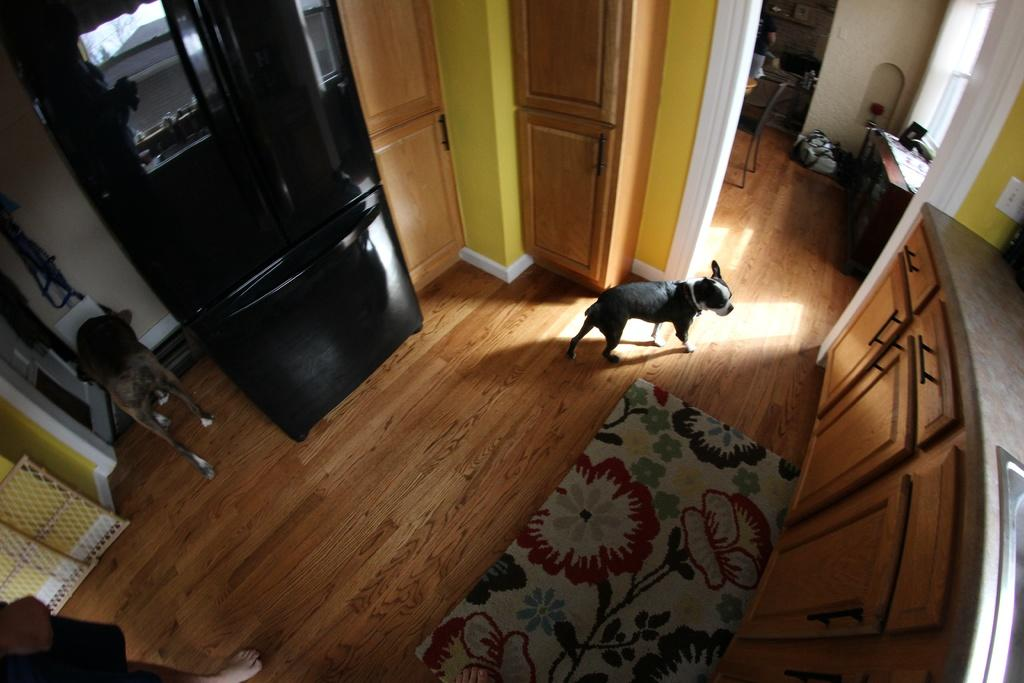How many dogs are in the image? There are two dogs in the image. What is the surface the dogs are standing on? The dogs are standing on a brown floor. Can you describe the presence of a person in the image? There is a person in the left corner of the image. What type of stitch is being used to sew the dogs' collars in the image? There is no indication in the image that the dogs are wearing collars, nor is there any mention of sewing or stitching. 